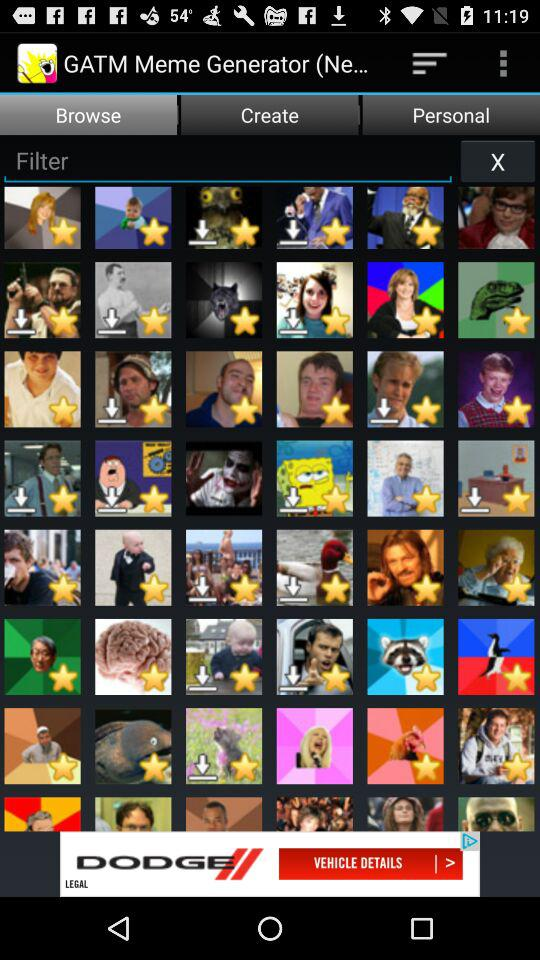Which tab is selected? The selected tab is "Browse". 